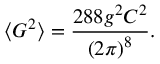<formula> <loc_0><loc_0><loc_500><loc_500>\langle G ^ { 2 } \rangle = \frac { 2 8 8 g ^ { 2 } C ^ { 2 } } { \left ( 2 \pi \right ) ^ { 8 } } .</formula> 